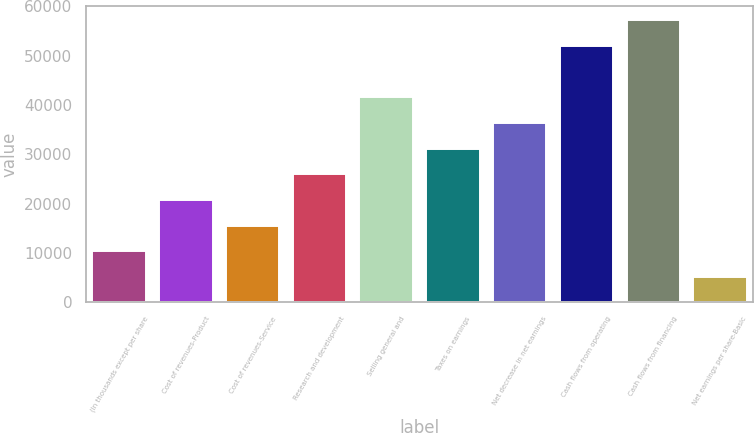Convert chart to OTSL. <chart><loc_0><loc_0><loc_500><loc_500><bar_chart><fcel>(In thousands except per share<fcel>Cost of revenues-Product<fcel>Cost of revenues-Service<fcel>Research and development<fcel>Selling general and<fcel>Taxes on earnings<fcel>Net decrease in net earnings<fcel>Cash flows from operating<fcel>Cash flows from financing<fcel>Net earnings per share-Basic<nl><fcel>10392.8<fcel>20785.3<fcel>15589<fcel>25981.6<fcel>41570.4<fcel>31177.9<fcel>36374.2<fcel>51963<fcel>57159.3<fcel>5196.48<nl></chart> 